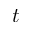<formula> <loc_0><loc_0><loc_500><loc_500>t</formula> 